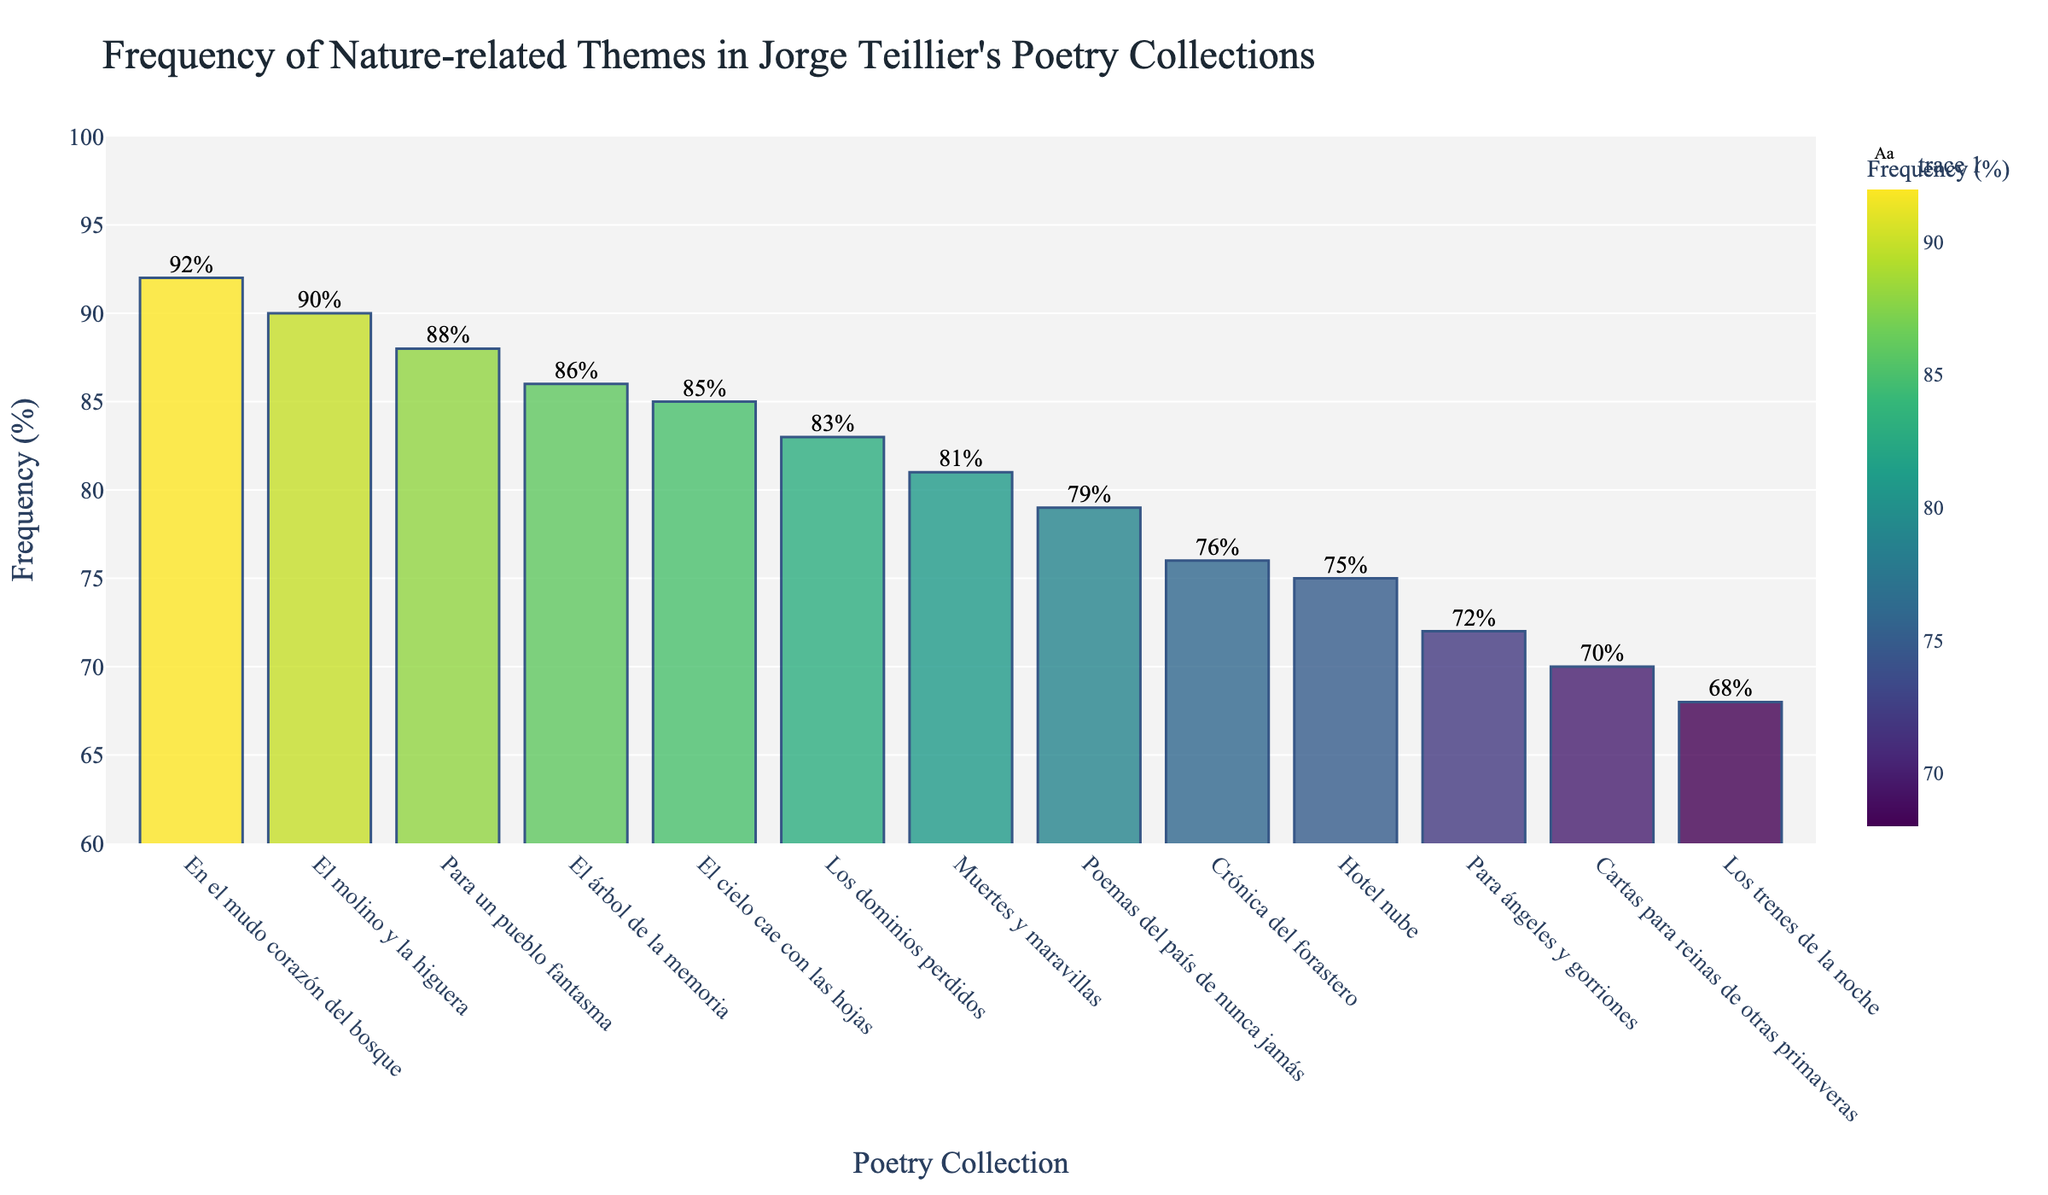Which poetry collection has the highest frequency of nature-related themes? The bar representing "En el mudo corazón del bosque" is tallest and colored with the highest intensity in the Viridis color scale, indicating it has the highest frequency.
Answer: En el mudo corazón del bosque Which two collections have the lowest frequency of nature-related themes? The bars representing "Los trenes de la noche" and "Cartas para reinas de otras primaveras" are the shortest, indicating they have the lowest frequencies.
Answer: Los trenes de la noche, Cartas para reinas de otras primaveras What is the difference between the highest and lowest frequencies of nature-related themes? The highest frequency is for "En el mudo corazón del bosque" at 92%, and the lowest is for "Los trenes de la noche" at 68%. The difference is 92% - 68%.
Answer: 24% What is the average frequency of nature-related themes across all collections? Sum all frequency values and divide by the number of collections: (68 + 72 + 85 + 79 + 76 + 81 + 88 + 70 + 83 + 90 + 75 + 86 + 92) / 13.
Answer: 80.77% Which collection has a frequency of nature-related themes greater than 80% but less than 90%? The bars representing "El cielo cae con las hojas" (85%), "Muertes y maravillas" (81%), "Para un pueblo fantasma" (88%), and "El árbol de la memoria" (86%) are within the range of 80% to 90%.
Answer: El cielo cae con las hojas, Muertes y maravillas, Para un pueblo fantasma, El árbol de la memoria How many collections have a frequency of nature-related themes above 75%? Count the bars where the frequency is greater than 75%. These collections are "El cielo cae con las hojas", "Poemas del país de nunca jamás", "Crónica del forastero", "Muertes y maravillas", "Para un pueblo fantasma", "Los dominios perdidos", "El molino y la higuera", "El árbol de la memoria", and "En el mudo corazón del bosque".
Answer: 9 What is the median frequency of nature-related themes among the collections? Sort the frequencies and find the middle value. The sorted frequencies are [68, 70, 72, 75, 76, 79, 81, 83, 85, 86, 88, 90, 92]. The middle value is the 7th number due to having 13 entries, which is 81%.
Answer: 81% Which collections have frequencies of nature-related themes that are exactly 85%? The bar labeled "El cielo cae con las hojas" reaches exactly 85% as indicated by the text annotation on top.
Answer: El cielo cae con las hojas Are there any collections where the frequency of nature-related themes is exactly 70%? The bar labeled "Cartas para reinas de otras primaveras" reaches exactly 70% as indicated by the text annotation on top.
Answer: Cartas para reinas de otras primaveras Which collections have a frequency of nature-related themes between 80% and 85%? The bars representing "Muertes y maravillas" (81%) and "Los dominios perdidos" (83%) fall within the range of 80% to 85%.
Answer: Muertes y maravillas, Los dominios perdidos 